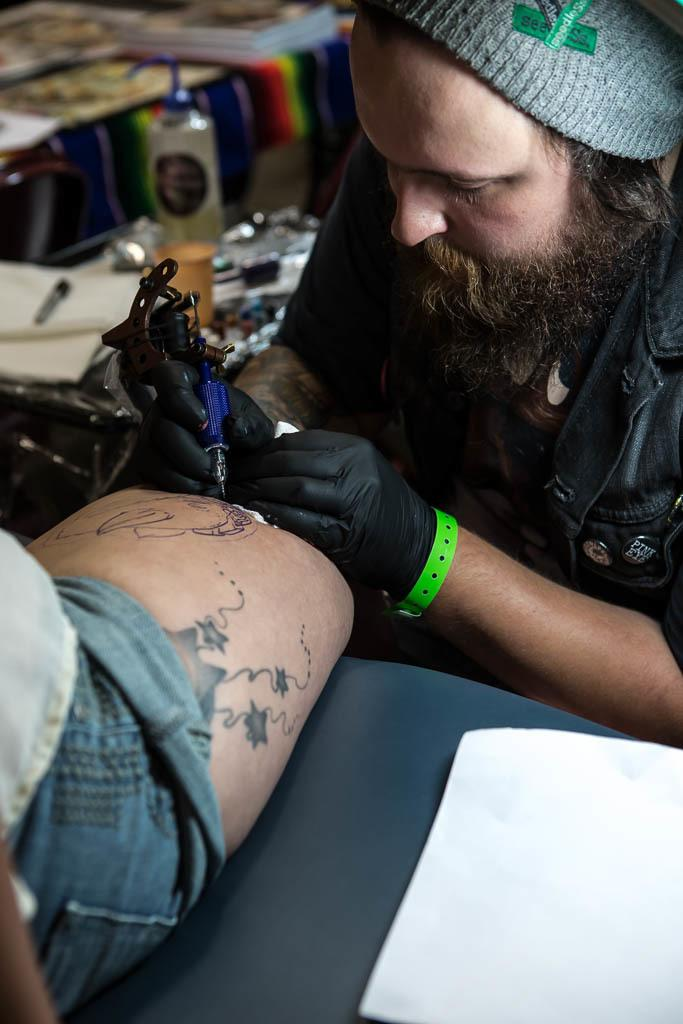What is the main subject of the image? There is a person in the image. Can you describe any distinguishing features of the person? The person has a tattoo on their hand. What can be observed about the background of the image? The background of the image is blurred. What type of education is the person pursuing in the image? There is no information about the person's education in the image. What kind of apparatus is being used by the person in the image? There is no apparatus visible in the image; it only features a person with a tattoo on their hand and a blurred background. 